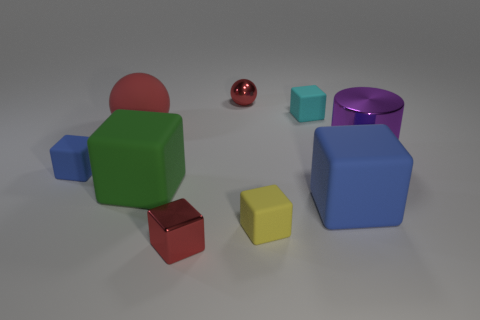What number of tiny objects are red cylinders or green blocks?
Your answer should be compact. 0. Do the cyan matte block and the shiny object in front of the cylinder have the same size?
Your answer should be very brief. Yes. How many other objects are there of the same shape as the yellow rubber object?
Provide a short and direct response. 5. The green thing that is the same material as the large blue cube is what shape?
Your response must be concise. Cube. Is there a big red matte ball?
Make the answer very short. Yes. Are there fewer large green rubber cubes in front of the tiny red shiny block than shiny things behind the tiny yellow cube?
Keep it short and to the point. Yes. There is a red shiny thing behind the small yellow block; what shape is it?
Your answer should be very brief. Sphere. Is the material of the tiny blue object the same as the purple cylinder?
Keep it short and to the point. No. Are there any other things that have the same material as the green object?
Offer a very short reply. Yes. What is the material of the small red object that is the same shape as the cyan object?
Your response must be concise. Metal. 